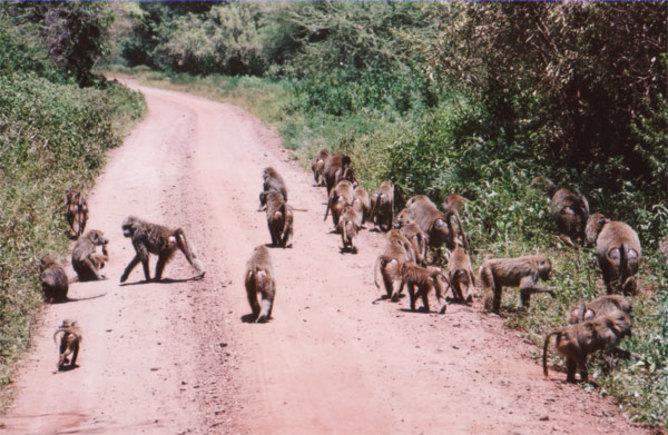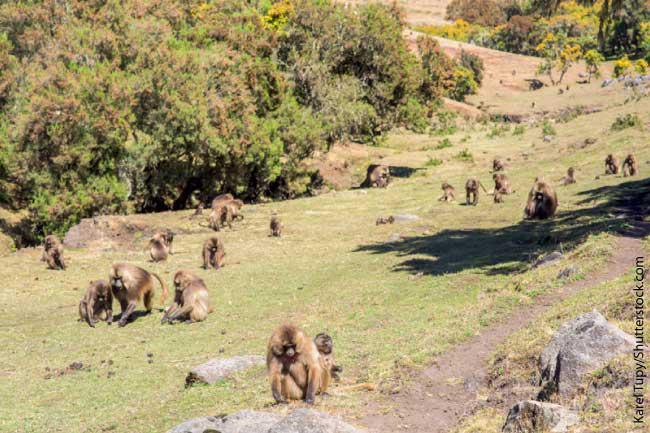The first image is the image on the left, the second image is the image on the right. Given the left and right images, does the statement "In one of the images all of the monkeys are walking down the road away from the camera." hold true? Answer yes or no. No. 